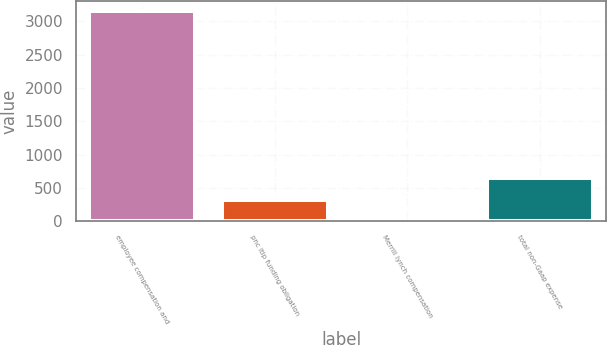<chart> <loc_0><loc_0><loc_500><loc_500><bar_chart><fcel>employee compensation and<fcel>pnc ltip funding obligation<fcel>Merrill lynch compensation<fcel>total non-Gaap expense<nl><fcel>3151<fcel>326.2<fcel>7<fcel>645.4<nl></chart> 